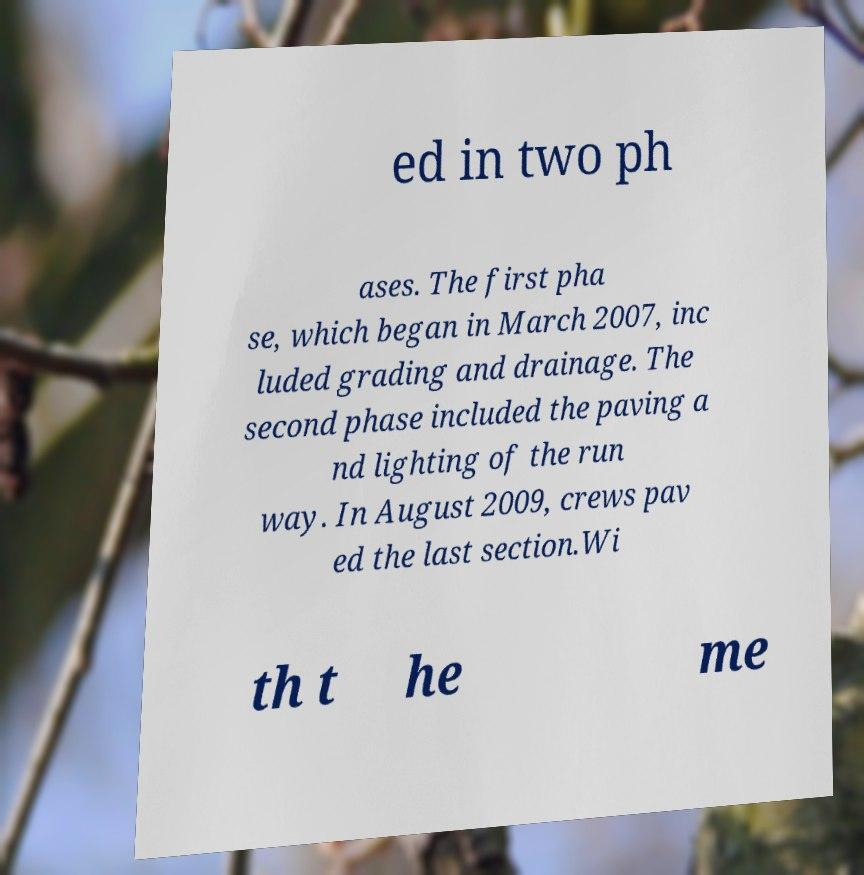For documentation purposes, I need the text within this image transcribed. Could you provide that? ed in two ph ases. The first pha se, which began in March 2007, inc luded grading and drainage. The second phase included the paving a nd lighting of the run way. In August 2009, crews pav ed the last section.Wi th t he me 